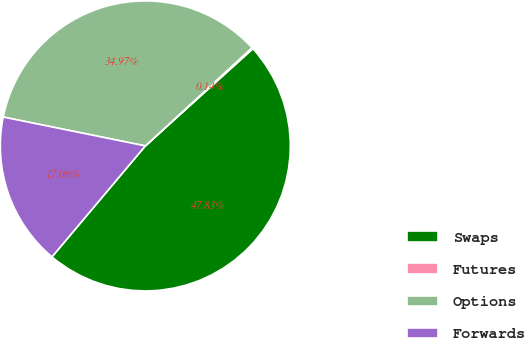Convert chart to OTSL. <chart><loc_0><loc_0><loc_500><loc_500><pie_chart><fcel>Swaps<fcel>Futures<fcel>Options<fcel>Forwards<nl><fcel>47.83%<fcel>0.14%<fcel>34.97%<fcel>17.06%<nl></chart> 